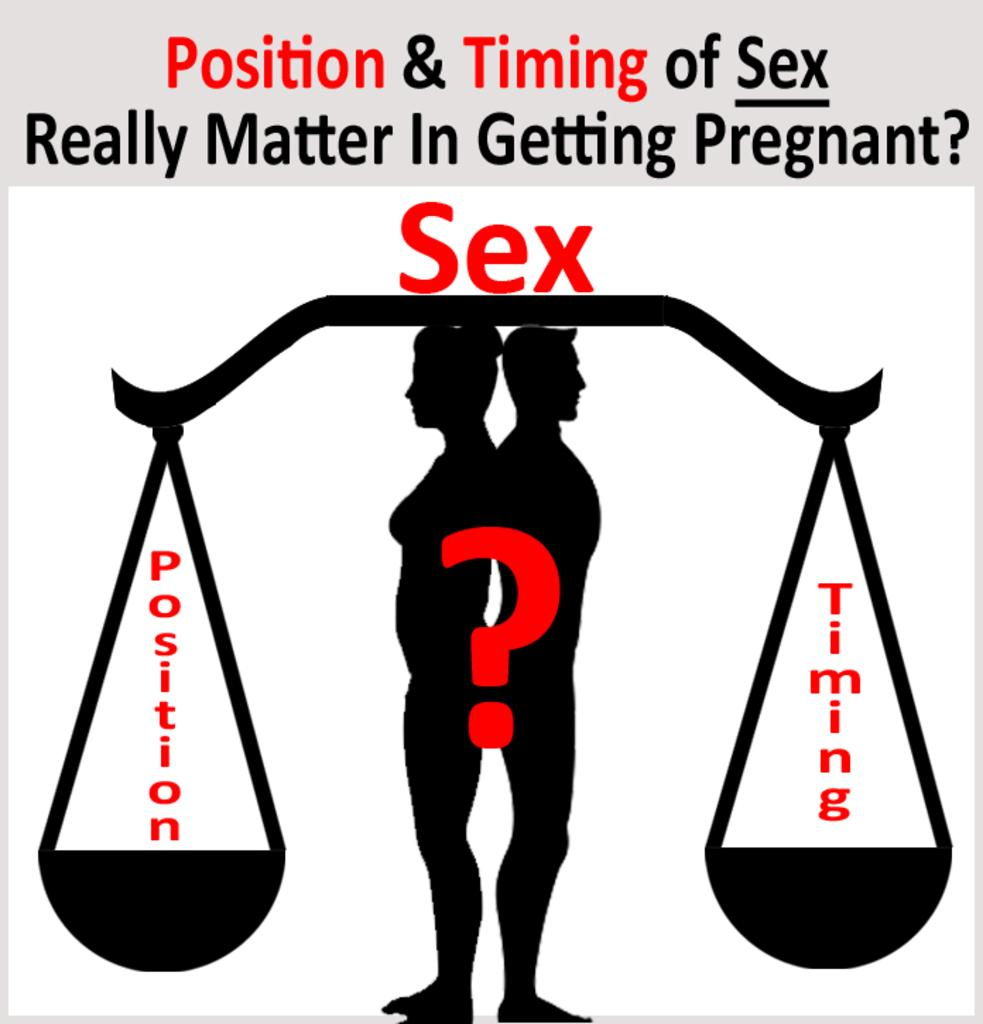<image>
Offer a succinct explanation of the picture presented. A graphic bringing up the question of position and timing during sex. 